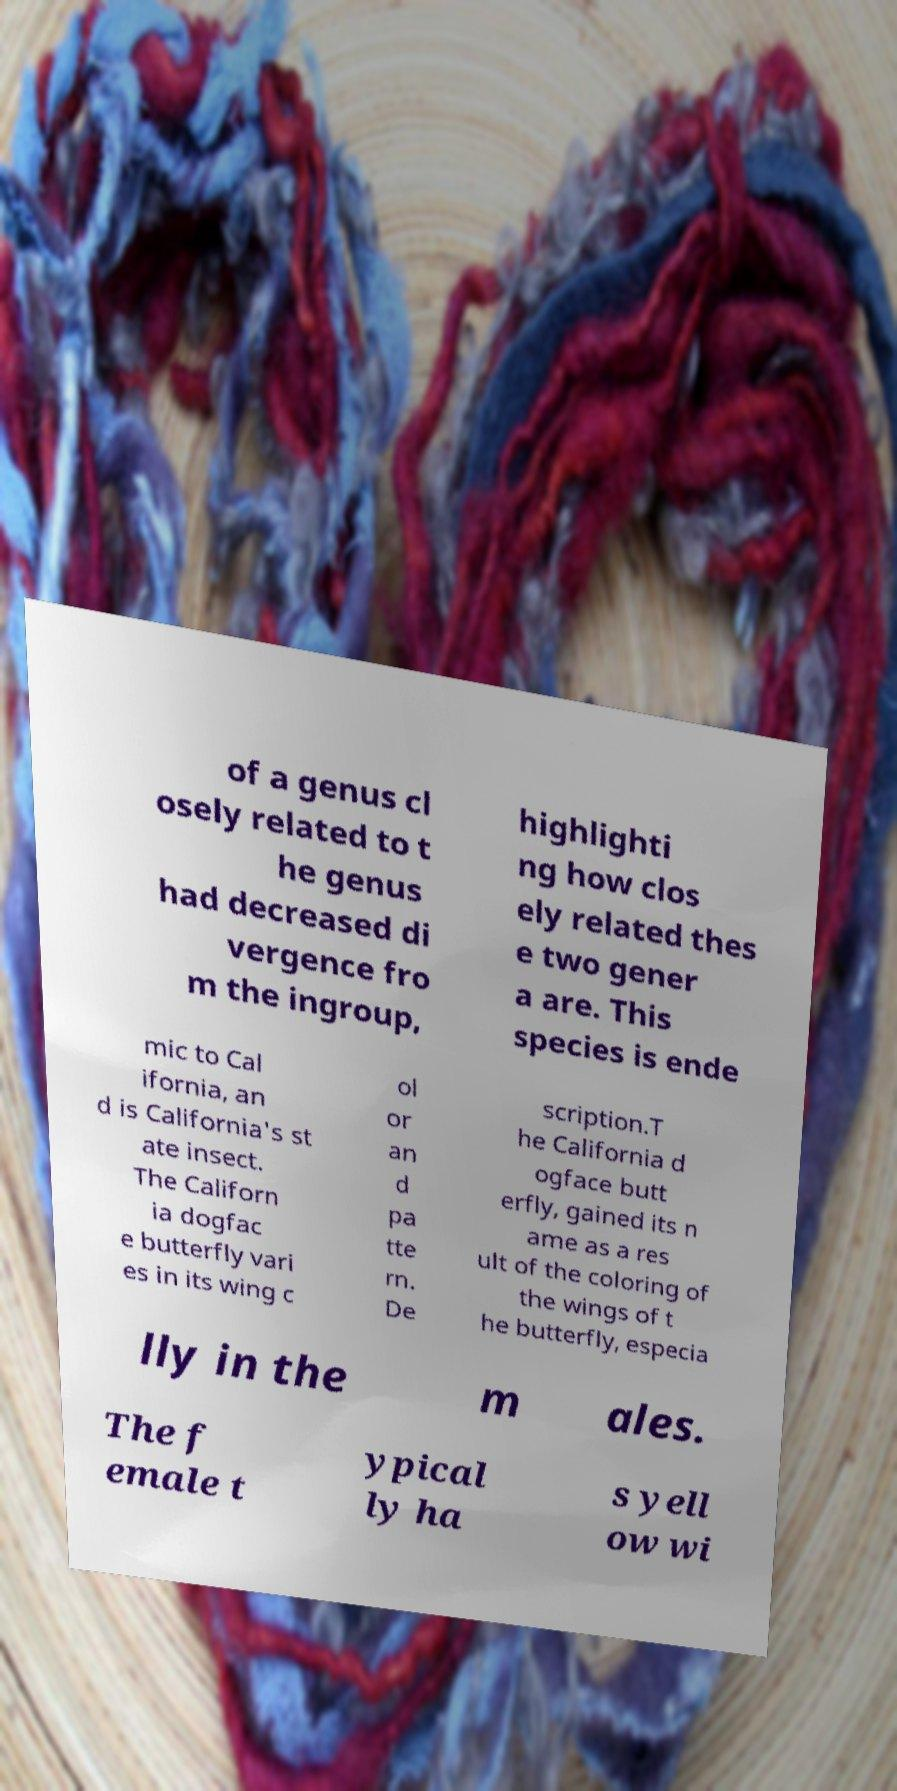I need the written content from this picture converted into text. Can you do that? of a genus cl osely related to t he genus had decreased di vergence fro m the ingroup, highlighti ng how clos ely related thes e two gener a are. This species is ende mic to Cal ifornia, an d is California's st ate insect. The Californ ia dogfac e butterfly vari es in its wing c ol or an d pa tte rn. De scription.T he California d ogface butt erfly, gained its n ame as a res ult of the coloring of the wings of t he butterfly, especia lly in the m ales. The f emale t ypical ly ha s yell ow wi 